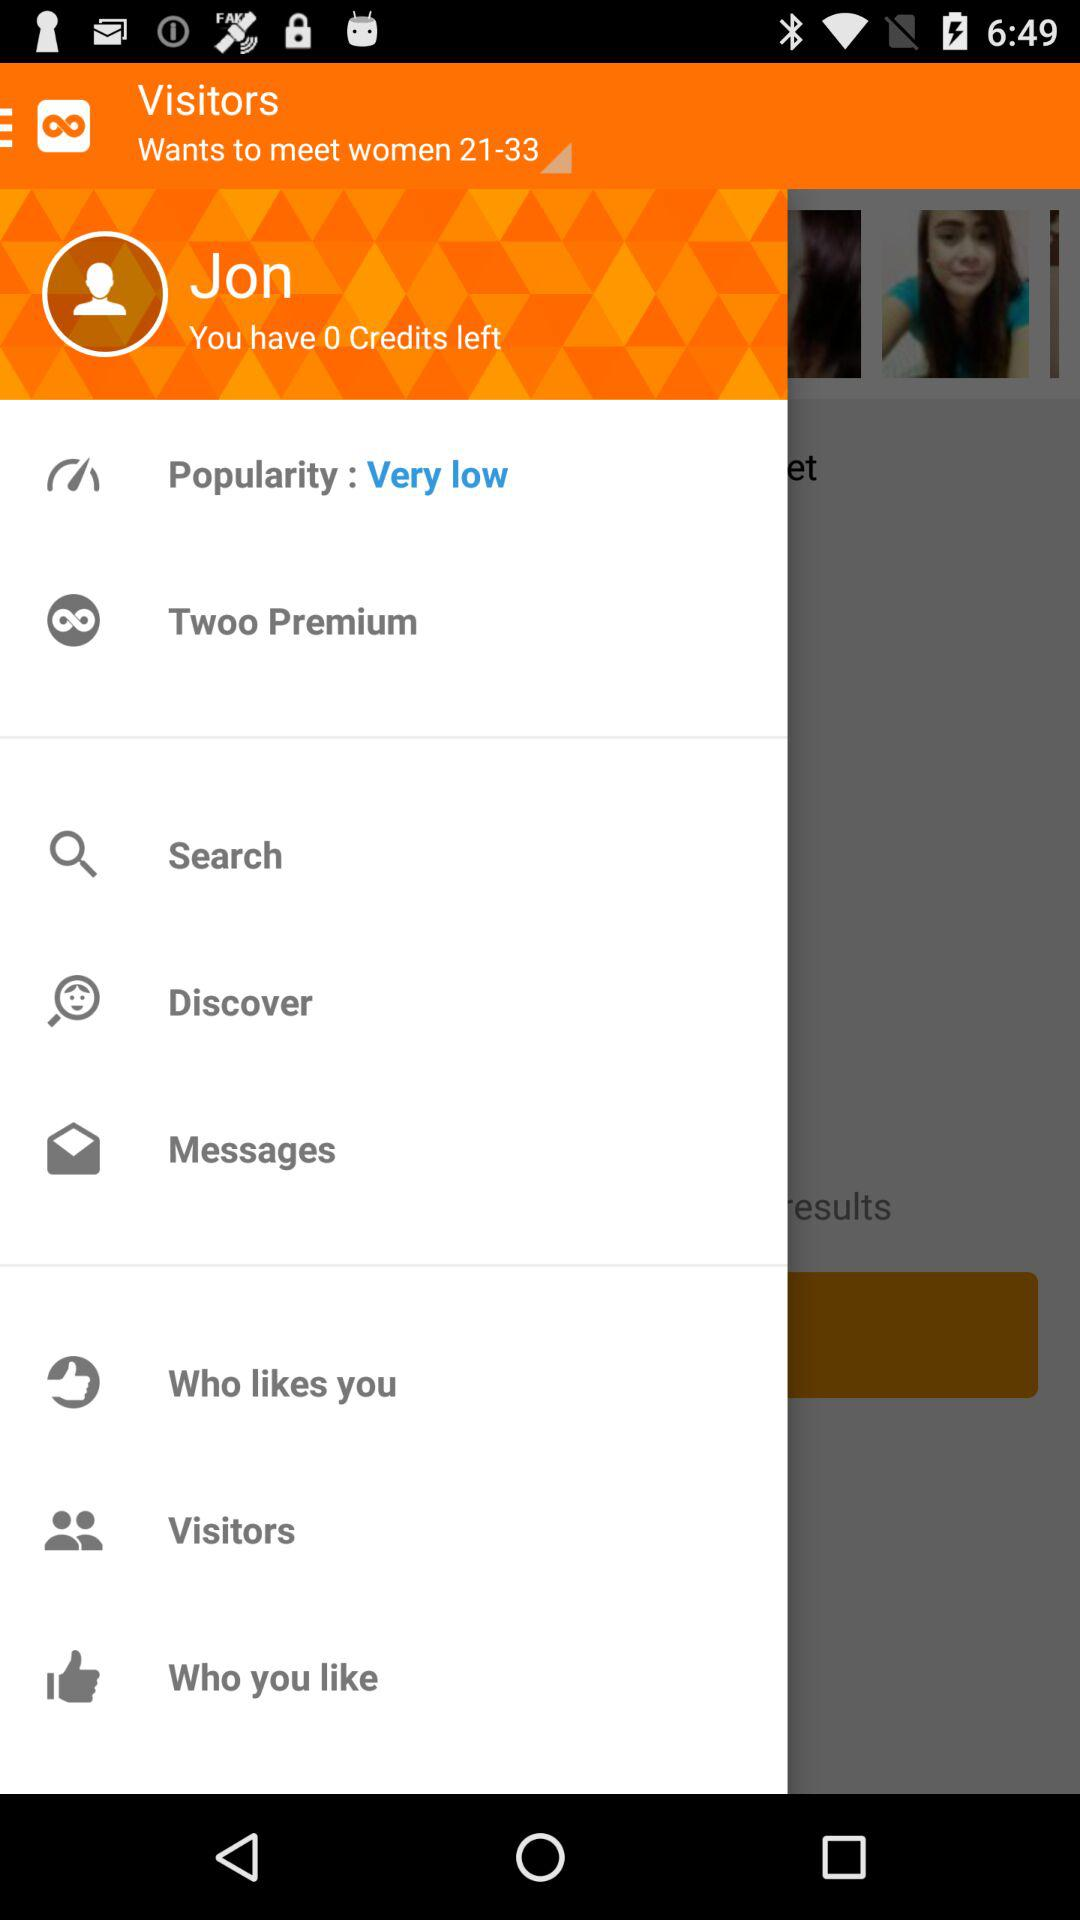How much credit is left? You have 0 credits left. 